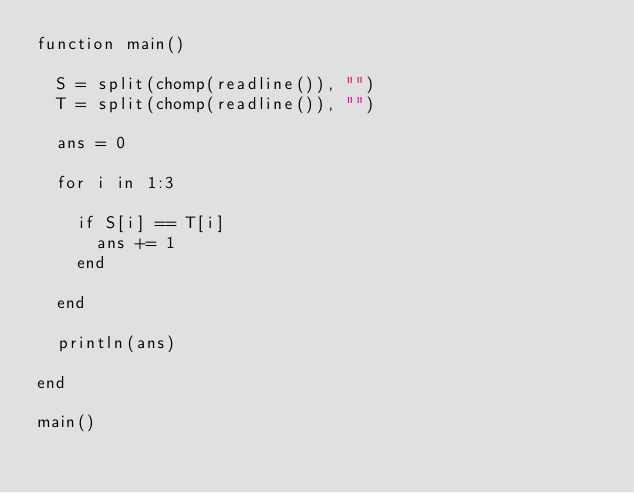Convert code to text. <code><loc_0><loc_0><loc_500><loc_500><_Julia_>function main()
  
  S = split(chomp(readline()), "")
  T = split(chomp(readline()), "")
  
  ans = 0
  
  for i in 1:3
    
    if S[i] == T[i]
      ans += 1
    end
    
  end
  
  println(ans)
  
end

main()</code> 